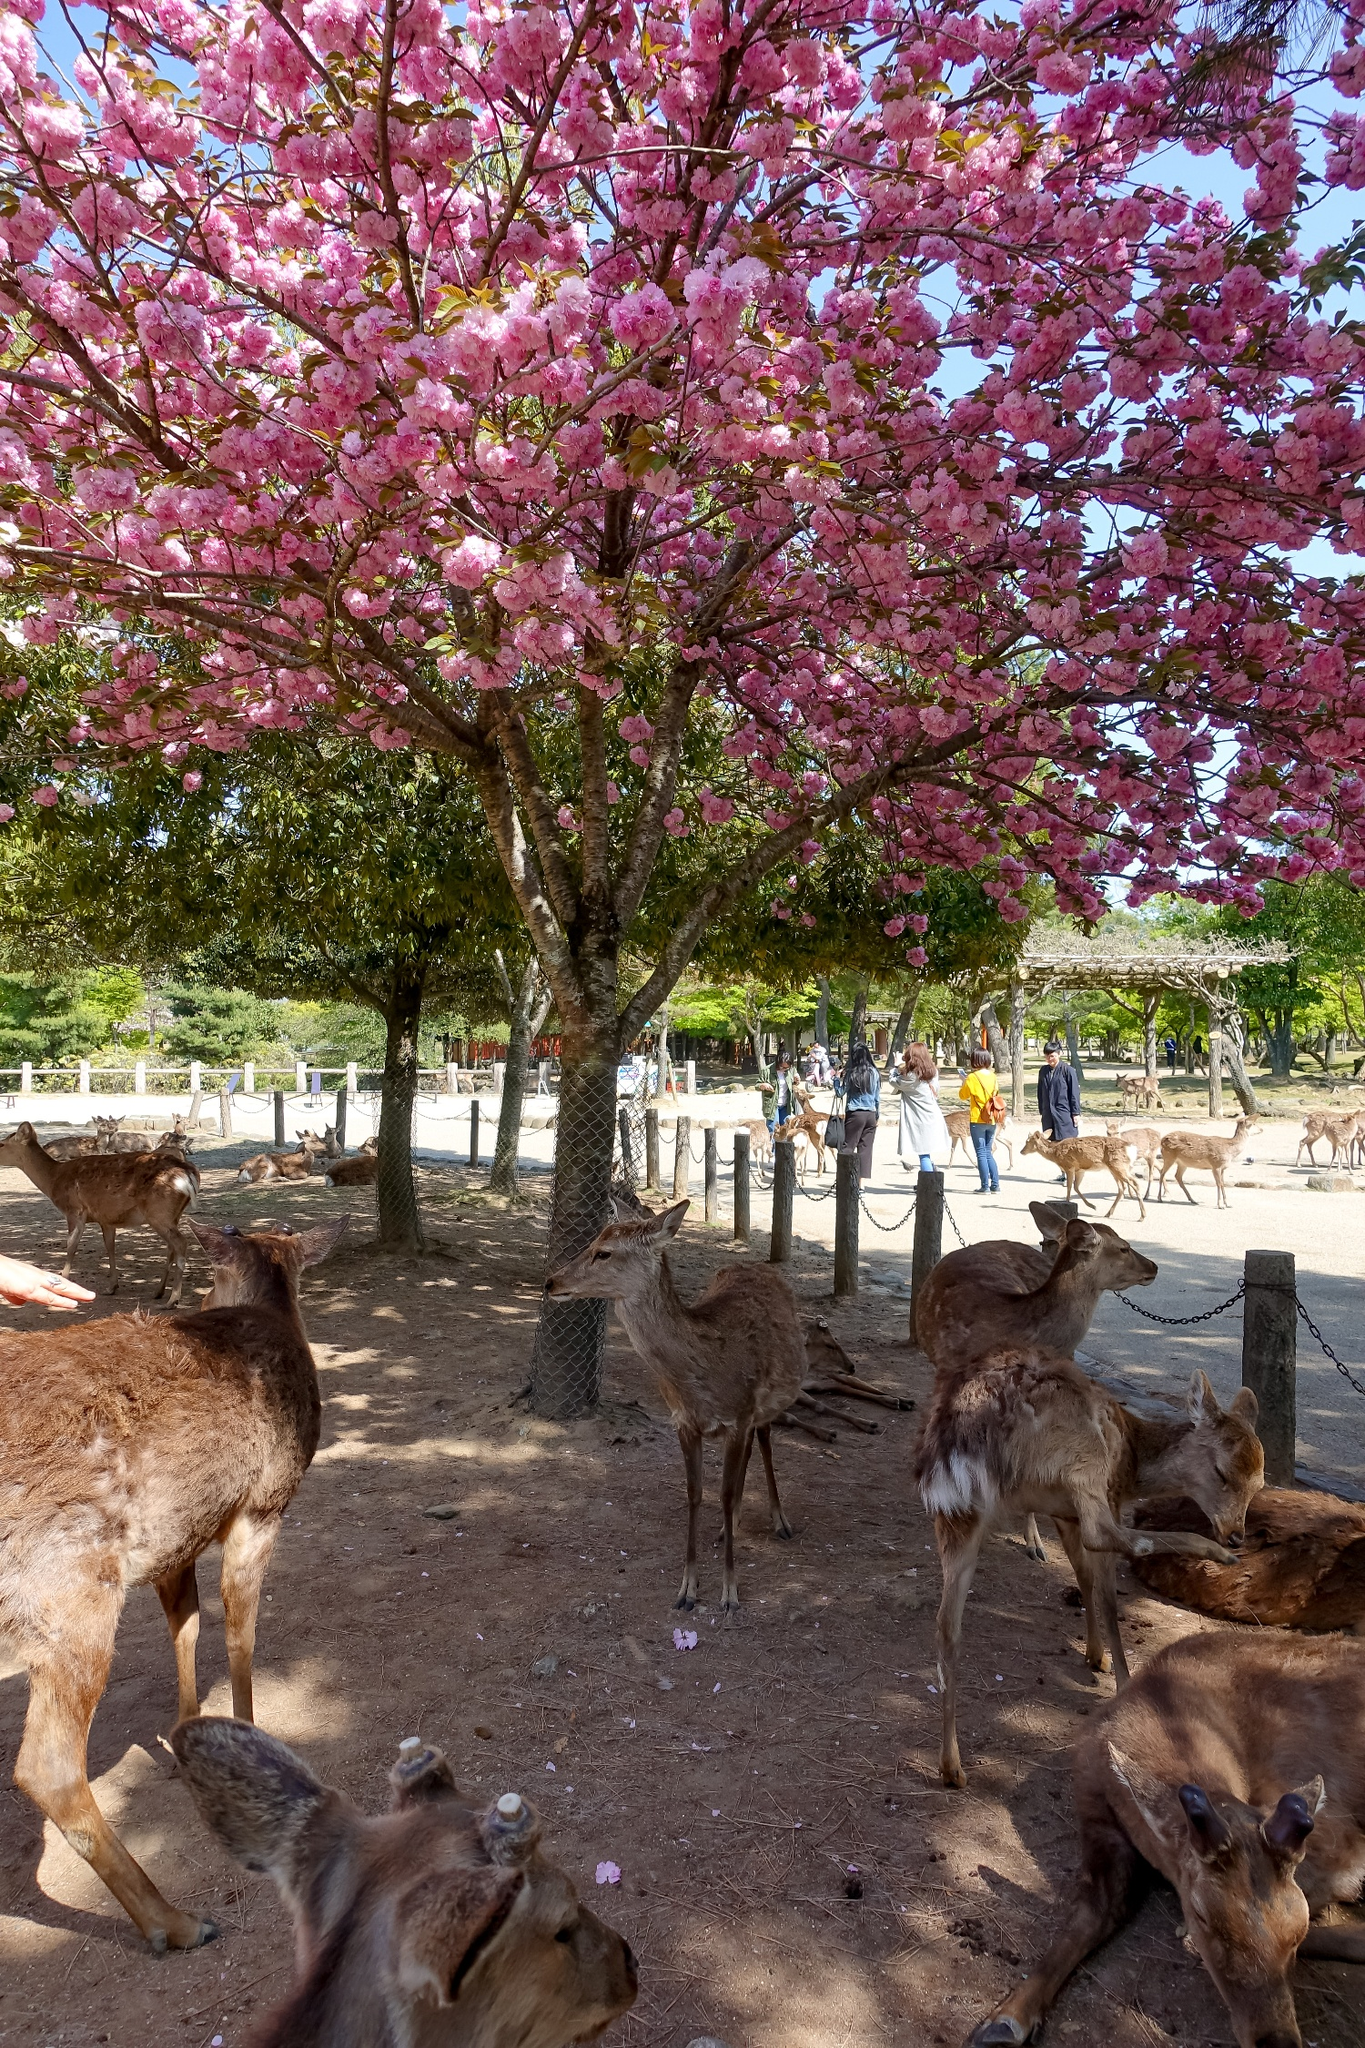Can you tell me a story about a day in the life of one of the deer in the park? Once upon a time in a serene park, a young deer named Luna woke up under the shade of a blooming cherry blossom tree. The soft pink petals gently fell around her as she stretched her legs and yawned. Luna loved mornings in the park; the air was fresh, and the sunlight filtered through the blossoms, casting a magical glow. As she grazed on the tender grass, she noticed children laughing and playing not far from her. Luna was curious and walked closer to watch them, careful to stay within the safety of the trees. Throughout the day, Luna wandered the park, meeting other deer and occasionally being fed by friendly visitors. As the day turned into dusk, Luna returned to her favorite spot under the cherry blossom tree, lying down to rest and enjoy the peaceful evening, knowing she was safe and cherished in this beautiful park. What would you highlight as the most beautiful aspect of this scene? The most beautiful aspect of this scene is undoubtedly the cherry blossom tree in full bloom. Its vibrant pink flowers create a picturesque canopy under which the deer rest peacefully. The contrast between the delicate blossoms and the serene deer captures a moment of natural beauty and tranquility. The overall harmony between the flora, fauna, and the subtle human presence in the background adds to the charm, evoking a sense of peace and unity with nature. 